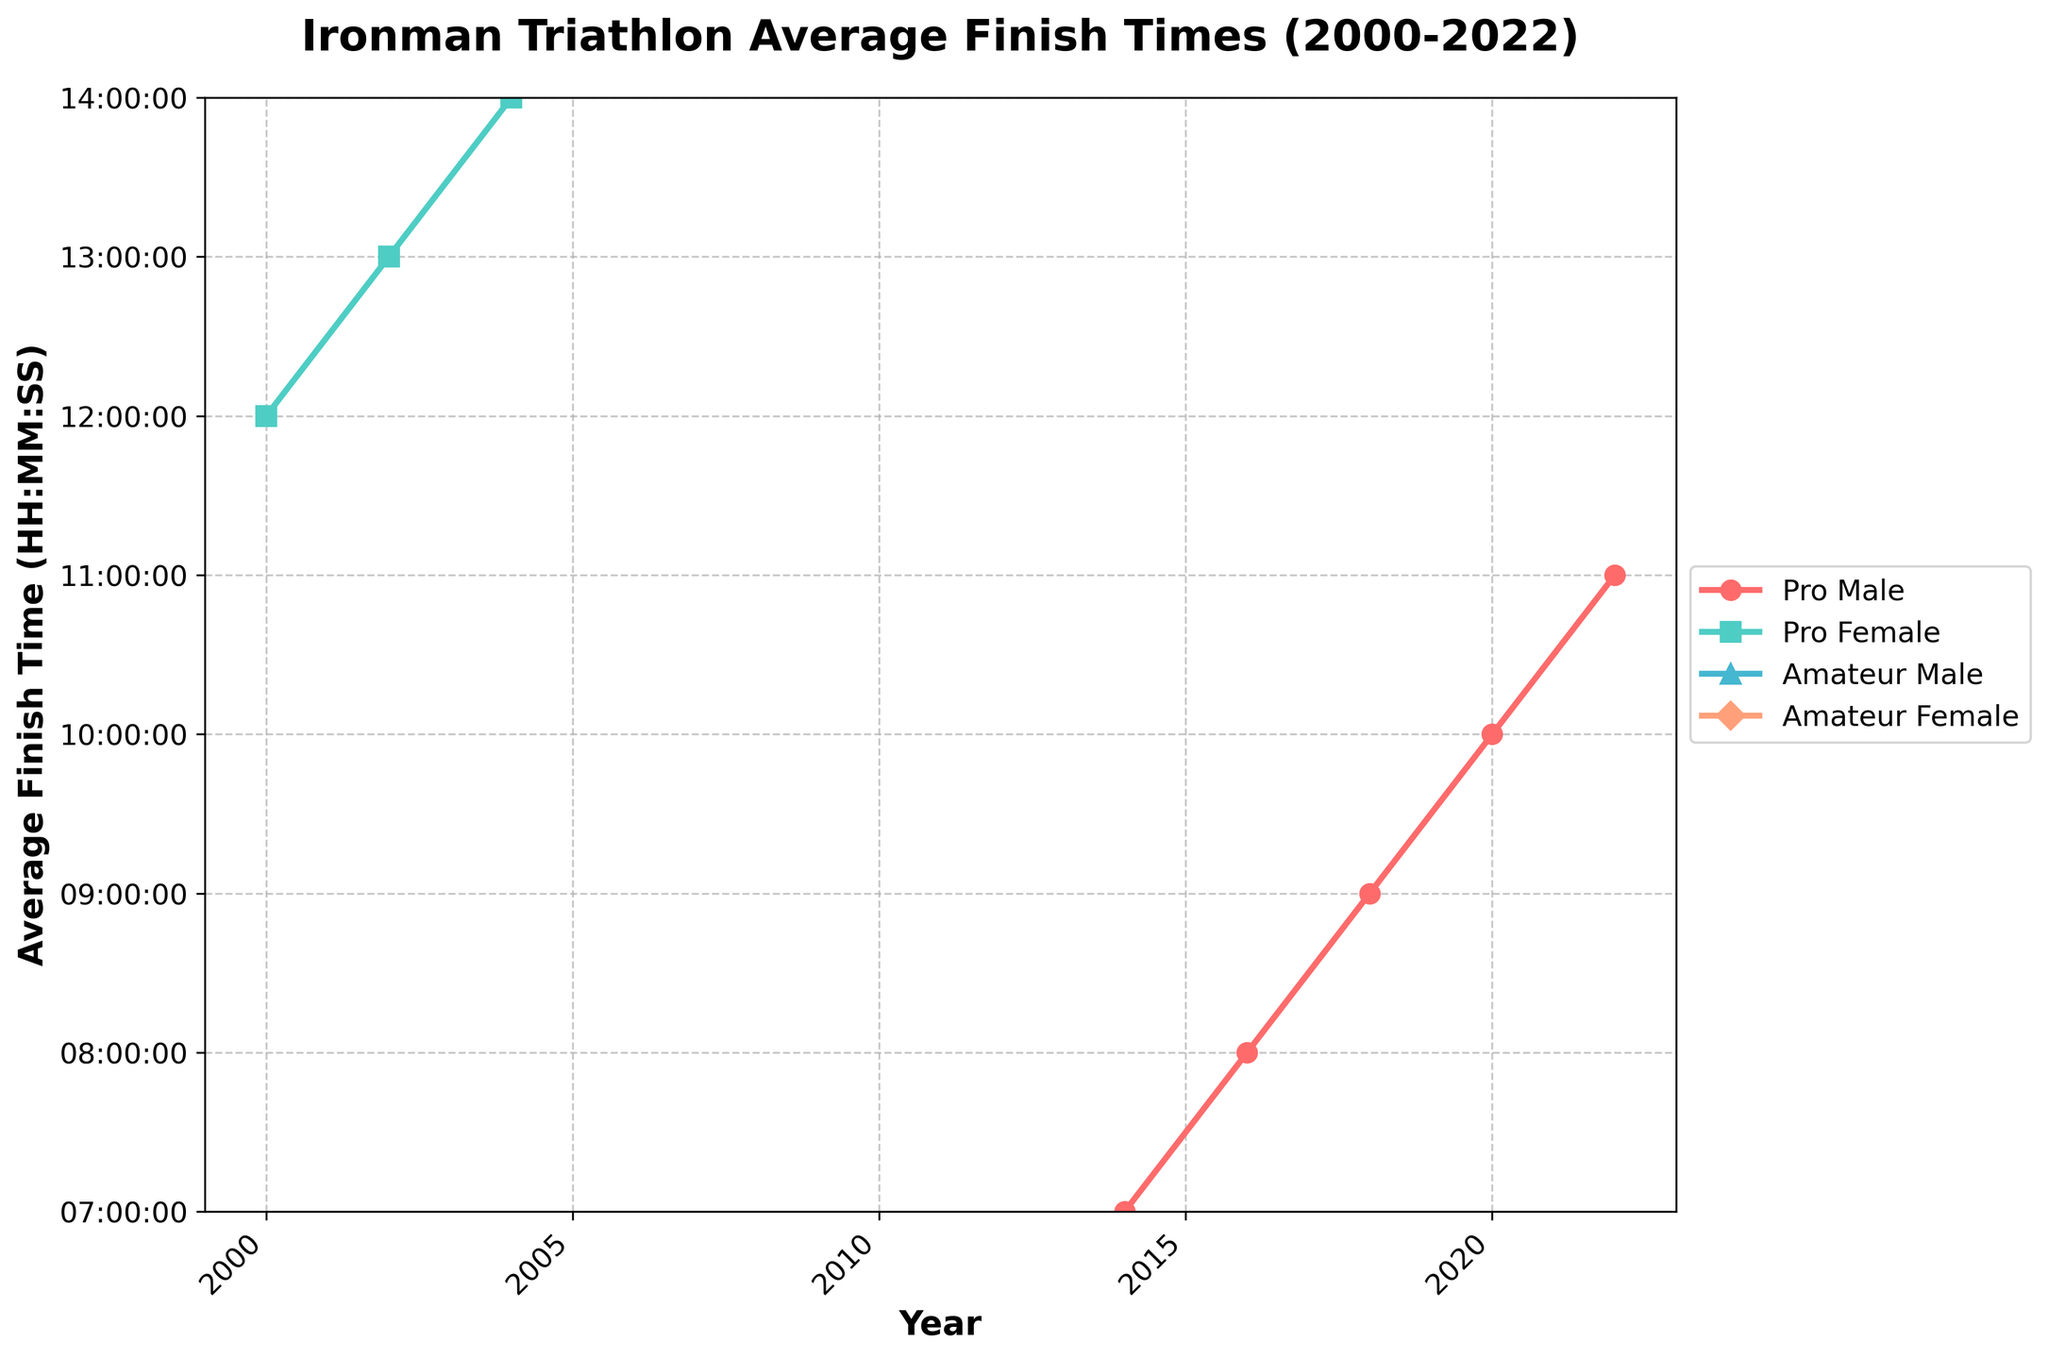What is the trend in finish times for Pro Male athletes from 2000 to 2022? To determine the trend, observe how the Pro Male average finish time changes from 2000 to 2022. From the figure, the Pro Male finish times decrease steadily from 8:20:15 in 2000 to 7:57:05 in 2022. This indicates a general improvement over time.
Answer: Decreasing How does the average finish time in 2022 for Amateur Male athletes compare with their finish time in 2000? To compare the finish times, look at the data points for Amateur Male athletes in 2000 and 2022. The finish time in 2000 is approximately 12:45:18, while in 2022 it is about 11:50:30. The finish time has decreased.
Answer: Decreased Which group showed the most consistent improvement in finish times from 2000 to 2022? To find the group with the most consistent improvement, compare the trend lines for all groups from 2000 to 2022. All groups show improvement, but the Professional Male group has a steady and notable decrease in finish times throughout the years.
Answer: Pro Male What is the difference between the fastest average finish time and the slowest average finish time in 2022? The fastest average finish time in 2022 is for Pro Male athletes at 7:57:05, and the slowest is for Amateur Female athletes at 12:35:55. Convert the times to seconds and find the difference: Pro Male = 28625 seconds, Amateur Female = 45355 seconds; Difference = 16730 seconds.
Answer: 16730 seconds Which category had the least improvement in finish times between 2000 and 2022? Compare the starting and ending points of each category's trend line from 2000 to 2022. Pro Females improved from 9:05:32 to 8:33:20, showing an improvement of about 32 minutes and 12 seconds. Other categories improved more.
Answer: Pro Female How do the average finish times for Pro Female athletes in 2010 and 2020 compare? Check the Pro Female average finish times for 2010 and 2020 on the graph. In 2010, it is 8:49:42, and in 2020, it is 8:35:30. On comparing, the time in 2020 is less than in 2010.
Answer: 2020 is faster What can you infer about the overall trend of finish times for Amateur Female athletes? Observe the trend line for Amateur Female athletes from 2000 to 2022. The line steadily decreases, indicating consistent improvements in finish times over the years.
Answer: Improvement Between Pro Male and Pro Female athletes, which group had a better improvement in their finish time from 2000 to 2022, and by how much? Calculate the difference in finish times for Pro Male from 2000 to 2022 (8:20:15 - 7:57:05) and for Pro Female from 2000 to 2022 (9:05:32 - 8:33:20). Convert the times to seconds: Pro Male = 13895 seconds improvement, Pro Female = 19312 seconds improvement. Pro Female improved more by 5417 seconds (19312-13895).
Answer: Pro Female, 5417 seconds Did any group reach an average finish time under 8 hours before 2018? Look for any data points below the 8-hour mark before 2018. All groups have finish times above the 8-hour mark until 2018 when Pro Male dropped below 8 hours.
Answer: No 